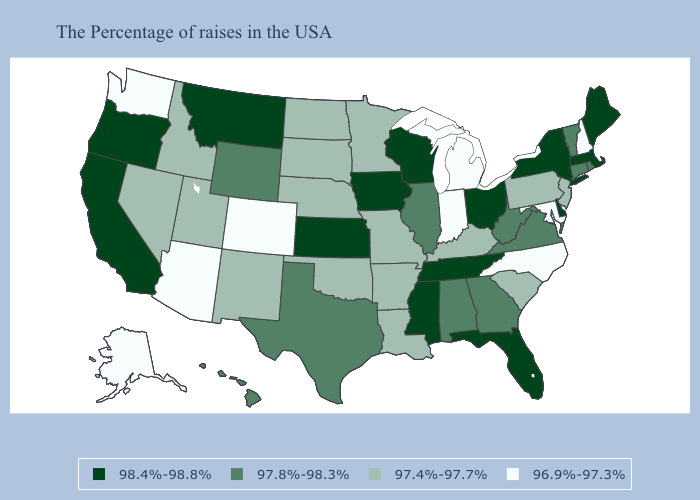Does the map have missing data?
Give a very brief answer. No. Does Oklahoma have a lower value than Kentucky?
Short answer required. No. Does Pennsylvania have the highest value in the USA?
Answer briefly. No. What is the highest value in states that border Maine?
Quick response, please. 96.9%-97.3%. What is the value of West Virginia?
Keep it brief. 97.8%-98.3%. Does Pennsylvania have the same value as Colorado?
Short answer required. No. Among the states that border Washington , does Oregon have the highest value?
Write a very short answer. Yes. What is the highest value in the West ?
Write a very short answer. 98.4%-98.8%. Does the first symbol in the legend represent the smallest category?
Short answer required. No. Among the states that border Michigan , which have the highest value?
Be succinct. Ohio, Wisconsin. What is the value of Tennessee?
Concise answer only. 98.4%-98.8%. Name the states that have a value in the range 97.4%-97.7%?
Keep it brief. New Jersey, Pennsylvania, South Carolina, Kentucky, Louisiana, Missouri, Arkansas, Minnesota, Nebraska, Oklahoma, South Dakota, North Dakota, New Mexico, Utah, Idaho, Nevada. Name the states that have a value in the range 98.4%-98.8%?
Quick response, please. Maine, Massachusetts, New York, Delaware, Ohio, Florida, Tennessee, Wisconsin, Mississippi, Iowa, Kansas, Montana, California, Oregon. Does Tennessee have the highest value in the South?
Keep it brief. Yes. What is the value of New Jersey?
Keep it brief. 97.4%-97.7%. 